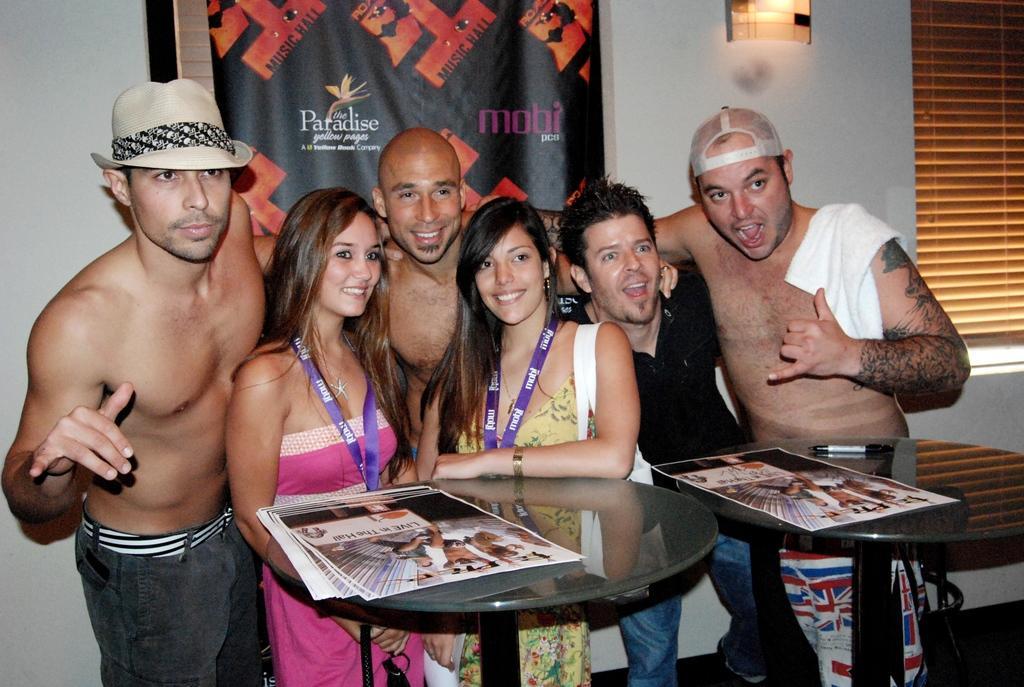Could you give a brief overview of what you see in this image? In this image on the right there is a man and there is a man, he wears a t shirt, trouser. In the middle there is a woman, she wears a yellow dress, tag and handbag and there is a woman, she wears a pink dress, tag and there is a man. On the left there is a man, he wears a trouser, hat. At the bottom there are tables on them there are papers, pen. In the background there are posters, windows, light and wall. 